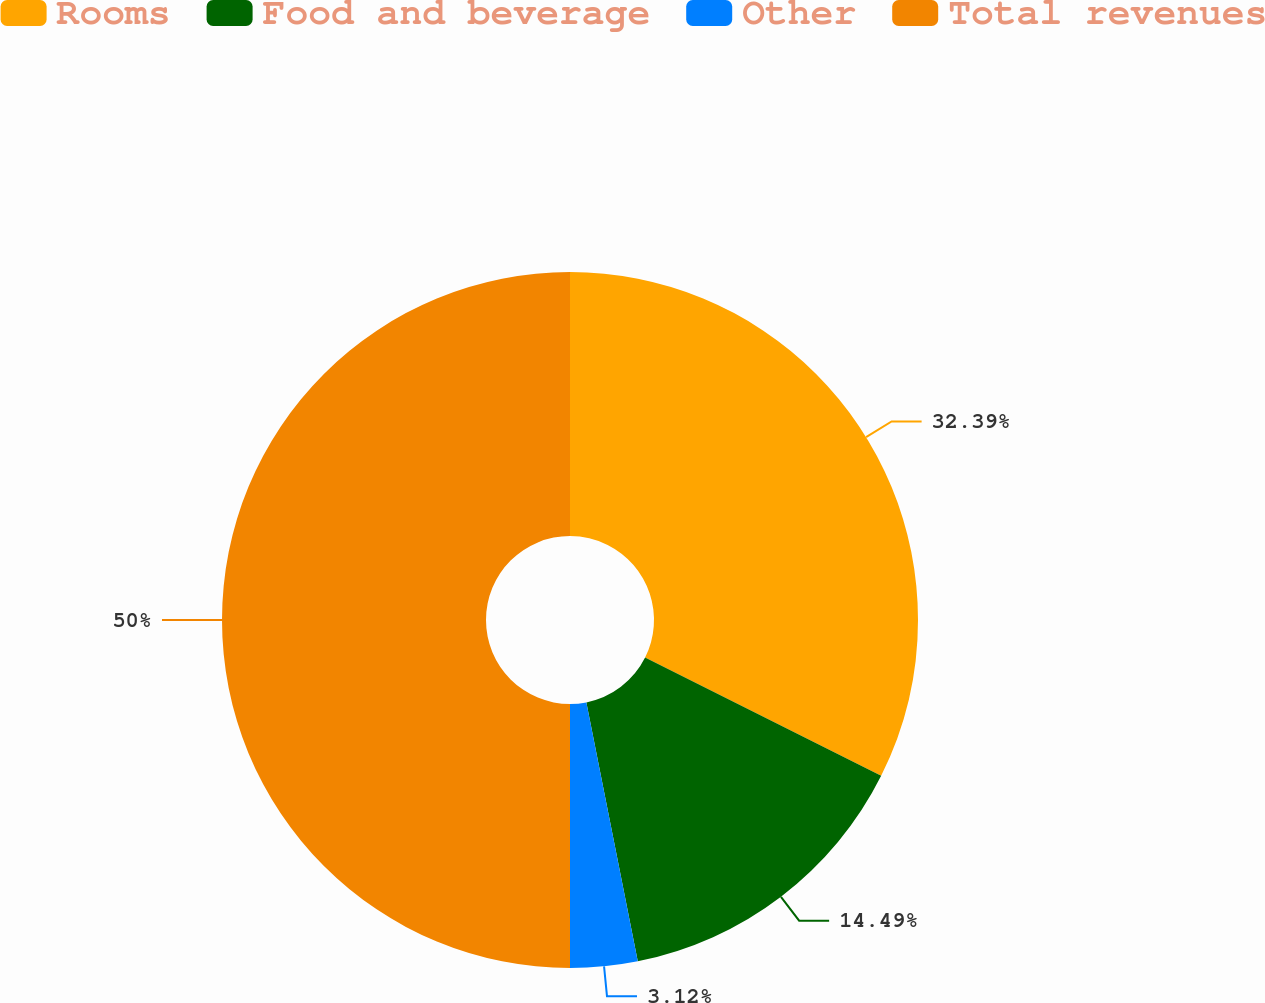Convert chart to OTSL. <chart><loc_0><loc_0><loc_500><loc_500><pie_chart><fcel>Rooms<fcel>Food and beverage<fcel>Other<fcel>Total revenues<nl><fcel>32.39%<fcel>14.49%<fcel>3.12%<fcel>50.0%<nl></chart> 